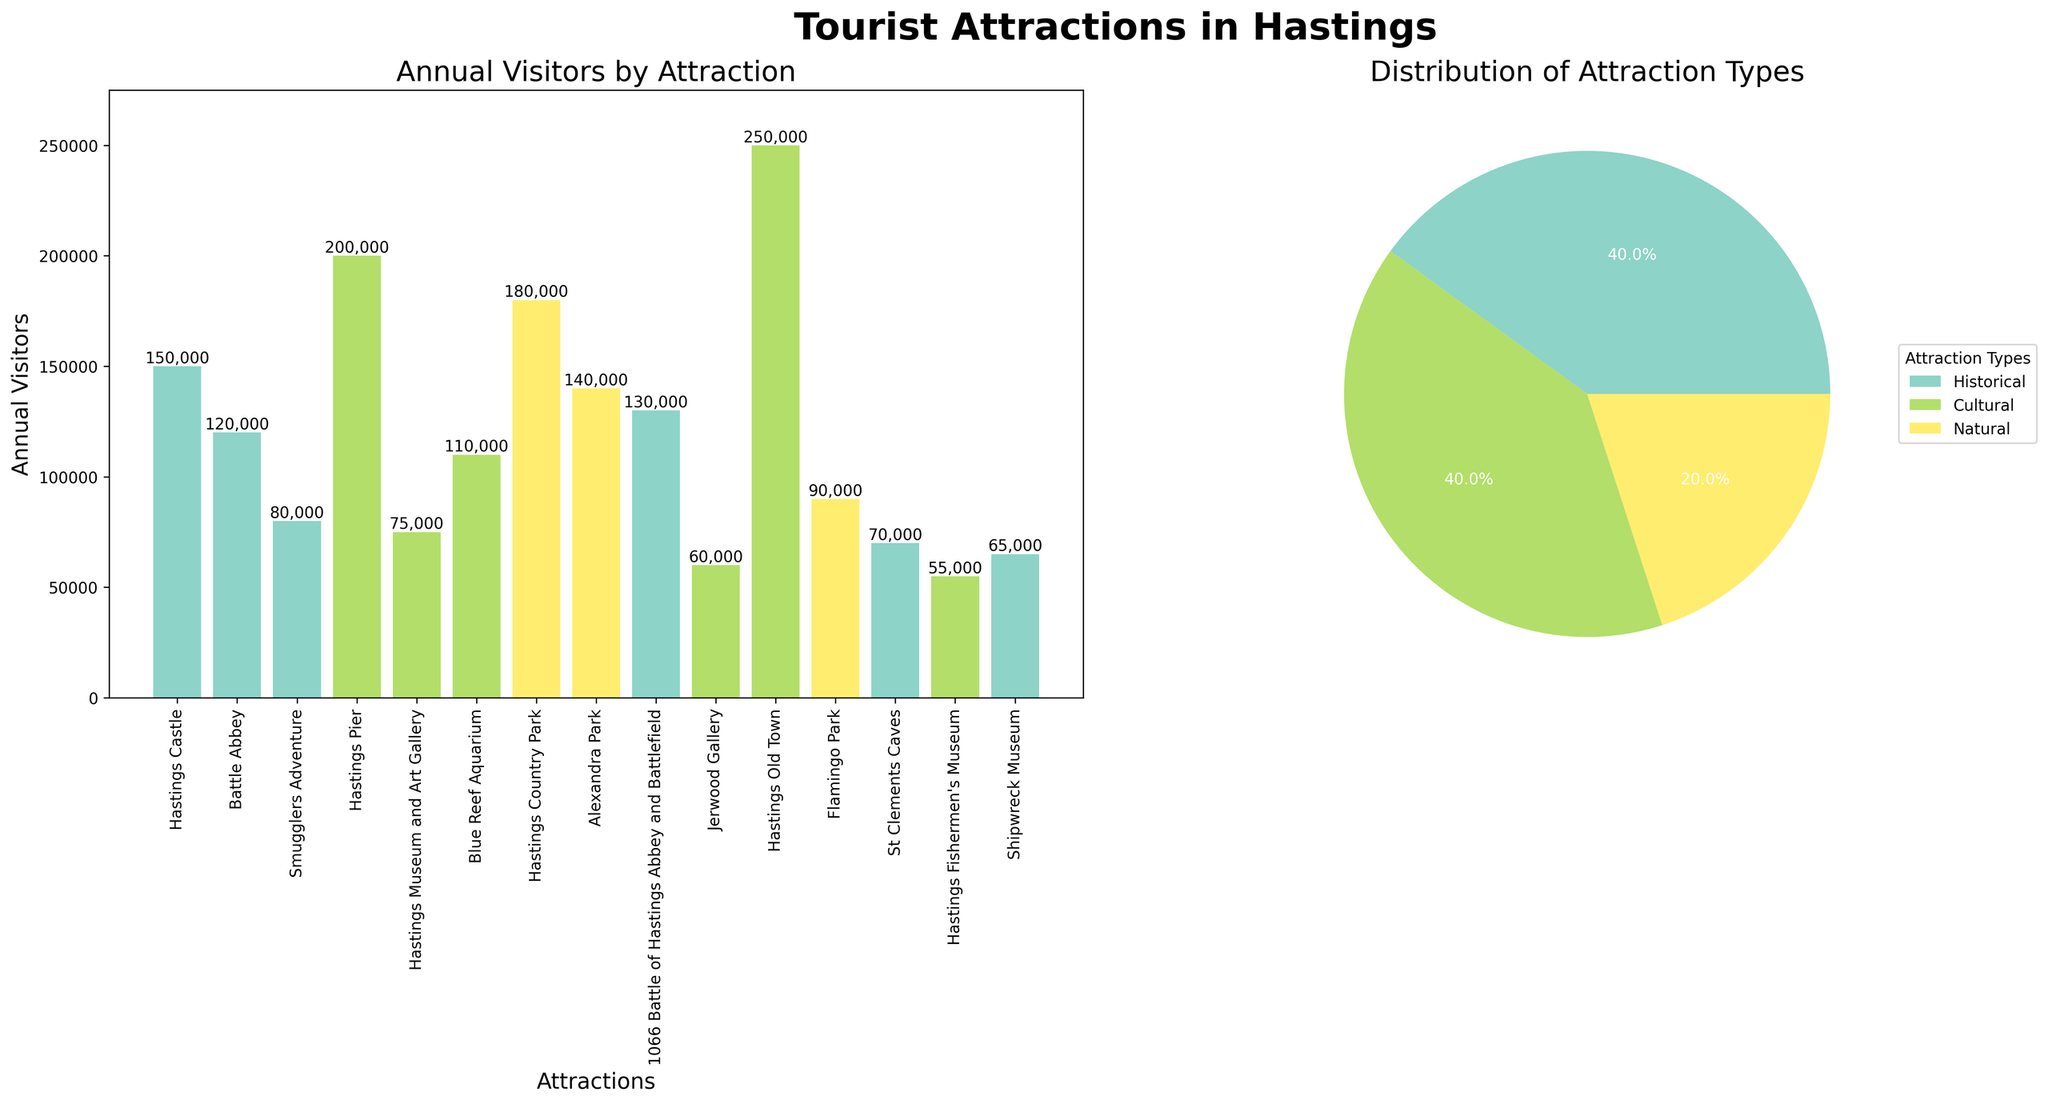what type of tourist attraction has the most visits annually? Looking at the bar plot, "Hastings Old Town" has the highest bar, indicating it has the most visits annually.
Answer: Hastings Old Town how many attractions belong to the Cultural category? The pie chart in the second subplot shows the distribution of attraction types, where we can see the proportion of each type. The legend shows 6 attractions belong to the Cultural category.
Answer: 6 which attraction receives the least annual visitors? The bar representing "Shipwreck Museum” is the shortest, indicating it receives the least annual visitors.
Answer: Shipwreck Museum what is the total number of annual visitors for Natural attractions? From the bar plot, we can sum up the annual visitors for Natural attractions: Hastings Country Park (180,000) + Alexandra Park (140,000) + Flamingo Park (90,000). Adding these numbers gives 410,000.
Answer: 410,000 how does the total number of annual visitors for cultural attractions compare to historical attractions? Sum the annual visitors for each category: Cultural (Hastings Pier: 200,000 + Hastings Museum and Art Gallery: 75,000 + Blue Reef Aquarium: 110,000 + Jerwood Gallery: 60,000 + Hastings Old Town: 250,000 + Hastings Fishermen's Museum: 55,000) totals to 750,000. Historical (Hastings Castle: 150,000 + Battle Abbey: 120,000 + Smugglers Adventure: 80,000 + 1066 Battle of Hastings Abbey and Battlefield: 130,000 + St Clements Caves: 70,000 + Shipwreck Museum: 65,000) totals to 615,000. Cultural has more visitors: 750,000 vs 615,000.
Answer: Cultural has more which historical attraction receives the most visitors annually? Comparing the heights of the bars in the Historical category in the bar plot, "Hastings Castle" has the highest bar, and thus the most visitors annually.
Answer: Hastings Castle what percentage of attractions are natural? Refer to the pie chart which shows the proportion of each type of attraction. The legend indicates that the Natural category makes up 20%.
Answer: 20% which bar is the tallest in the sub-graph of annual visitors by attraction? The tallest bar corresponds to "Hastings Old Town".
Answer: Hastings Old Town how many categories of attractions are there? The legend and different colors in the pie chart show three categories: Historical, Natural, and Cultural.
Answer: 3 